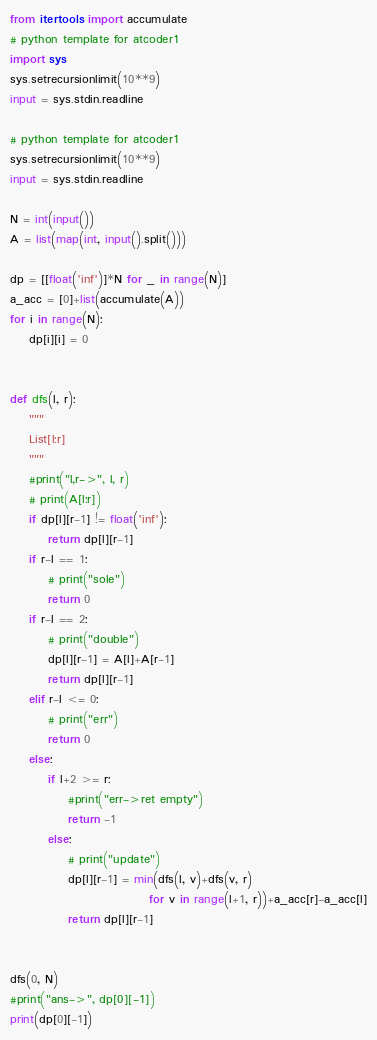Convert code to text. <code><loc_0><loc_0><loc_500><loc_500><_Python_>from itertools import accumulate
# python template for atcoder1
import sys
sys.setrecursionlimit(10**9)
input = sys.stdin.readline

# python template for atcoder1
sys.setrecursionlimit(10**9)
input = sys.stdin.readline

N = int(input())
A = list(map(int, input().split()))

dp = [[float('inf')]*N for _ in range(N)]
a_acc = [0]+list(accumulate(A))
for i in range(N):
    dp[i][i] = 0


def dfs(l, r):
    """
    List[l:r]
    """
    #print("l,r->", l, r)
    # print(A[l:r])
    if dp[l][r-1] != float('inf'):
        return dp[l][r-1]
    if r-l == 1:
        # print("sole")
        return 0
    if r-l == 2:
        # print("double")
        dp[l][r-1] = A[l]+A[r-1]
        return dp[l][r-1]
    elif r-l <= 0:
        # print("err")
        return 0
    else:
        if l+2 >= r:
            #print("err->ret empty")
            return -1
        else:
            # print("update")
            dp[l][r-1] = min(dfs(l, v)+dfs(v, r)
                             for v in range(l+1, r))+a_acc[r]-a_acc[l]
            return dp[l][r-1]


dfs(0, N)
#print("ans->", dp[0][-1])
print(dp[0][-1])
</code> 